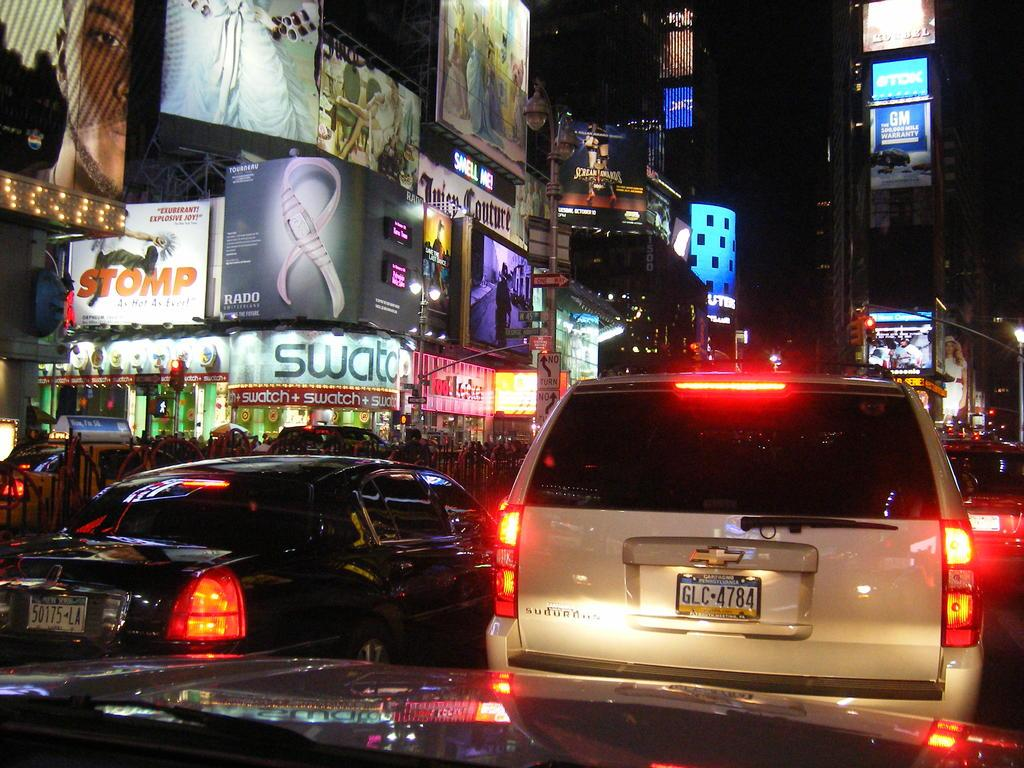Provide a one-sentence caption for the provided image. Chevy truck with license GLC4784 stuck in night traffic. 